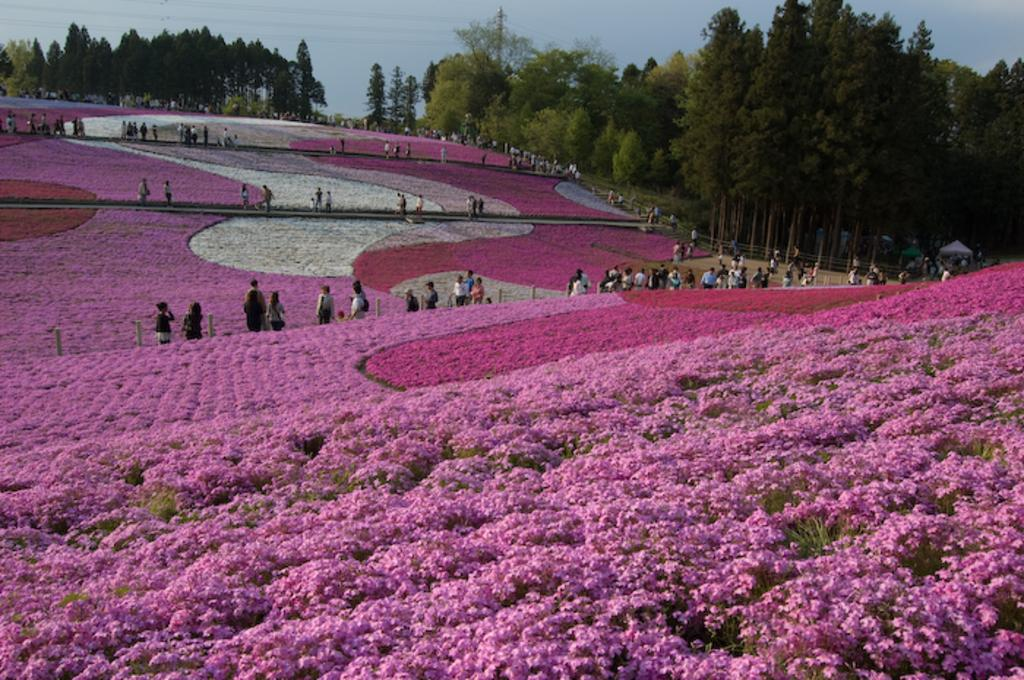What can be found in the foreground of the image? There is a flower bed in the image. Are there any people present in the image? Yes, there are people in the image. What can be seen in the background of the image? There are trees and the sky visible in the background of the image. What type of watch is the tree wearing in the image? There are no watches present in the image, and trees do not wear watches. 